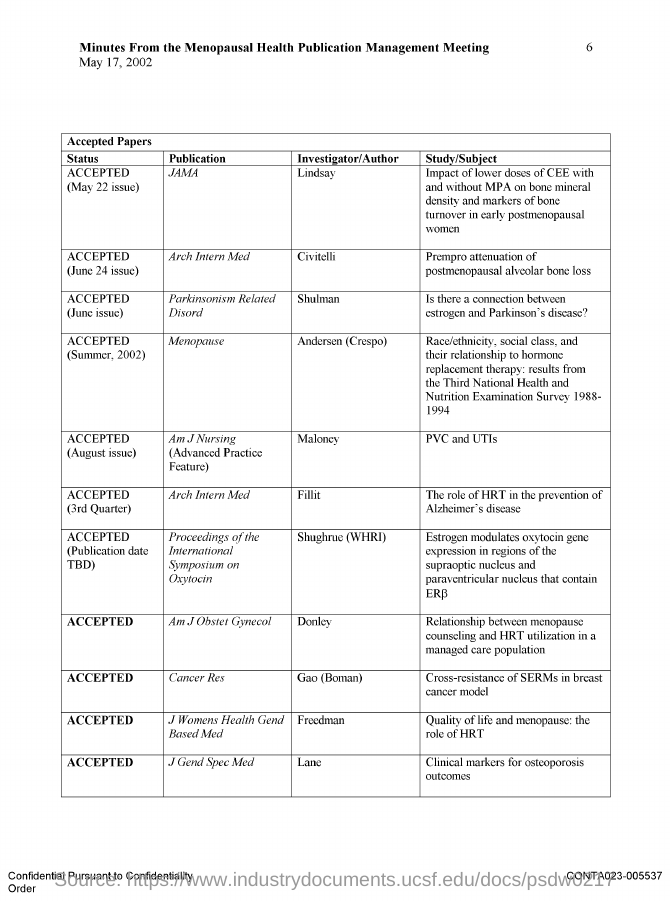Indicate a few pertinent items in this graphic. The document was dated May 17, 2002. A study by Civitelli investigated the effect of Prempro on postmenopausal alveolar bone loss. The document is about the minutes of a meeting regarding the management of publications related to menopausal health. The article "Cross-resistance of SERMs in breast cancer model" has been accepted for publication. I have published a document titled "PVC and UTIs" in the Advanced Practice Feature section of the American Journal of Nursing. 